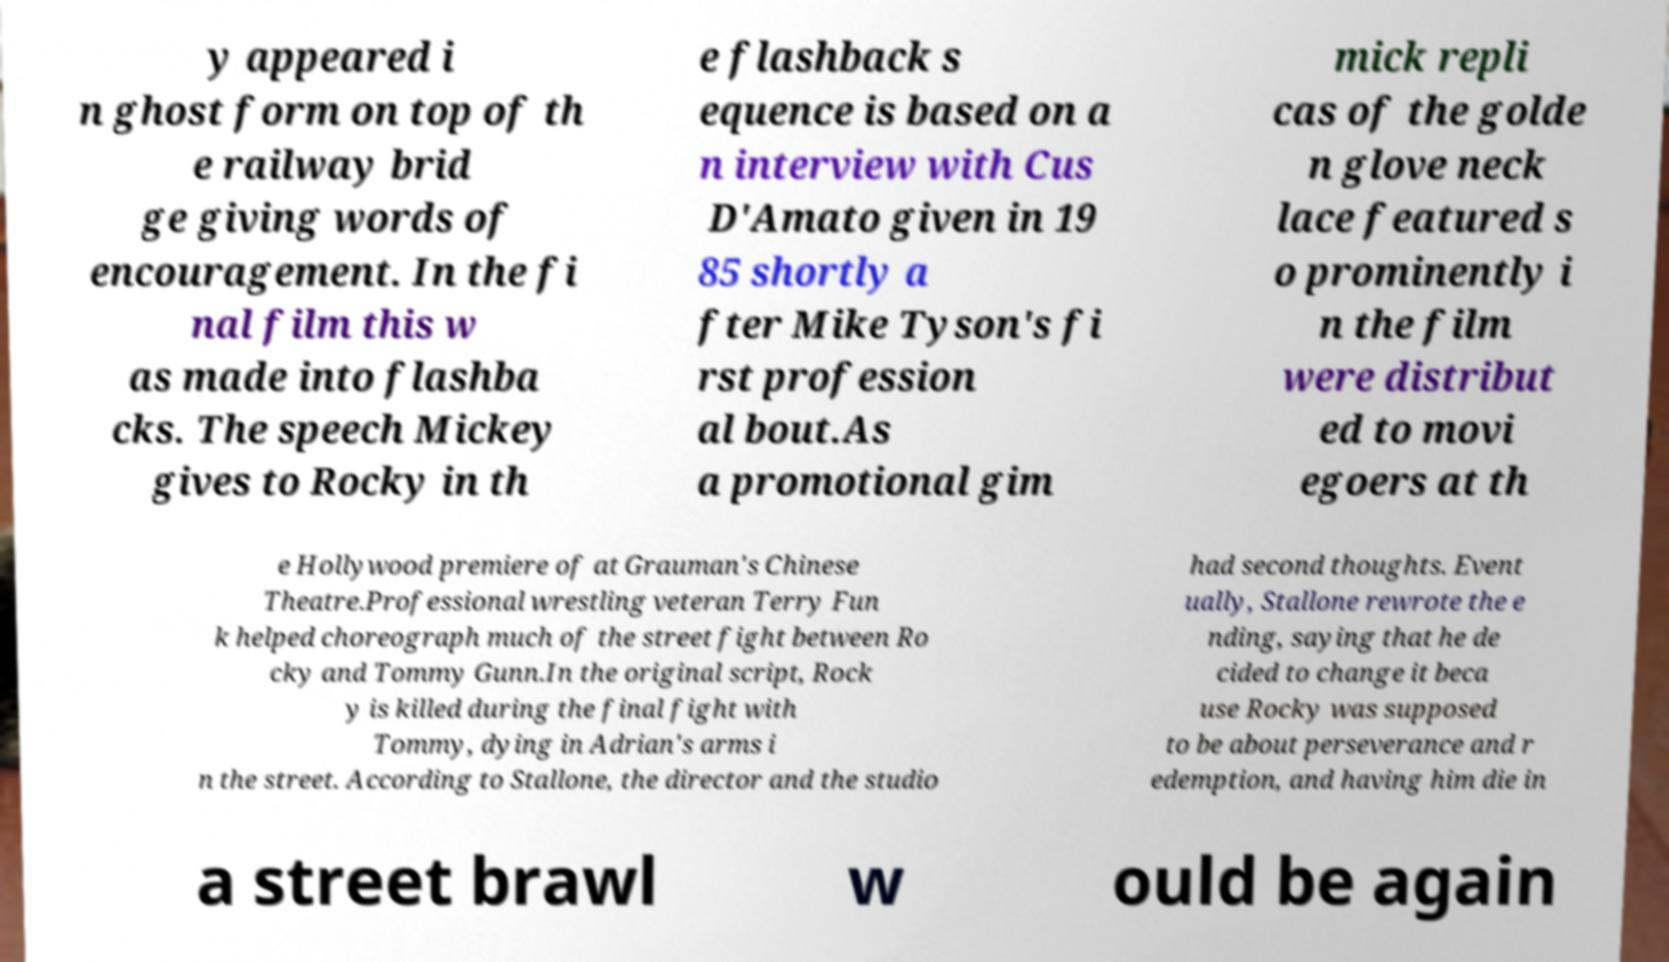There's text embedded in this image that I need extracted. Can you transcribe it verbatim? y appeared i n ghost form on top of th e railway brid ge giving words of encouragement. In the fi nal film this w as made into flashba cks. The speech Mickey gives to Rocky in th e flashback s equence is based on a n interview with Cus D'Amato given in 19 85 shortly a fter Mike Tyson's fi rst profession al bout.As a promotional gim mick repli cas of the golde n glove neck lace featured s o prominently i n the film were distribut ed to movi egoers at th e Hollywood premiere of at Grauman's Chinese Theatre.Professional wrestling veteran Terry Fun k helped choreograph much of the street fight between Ro cky and Tommy Gunn.In the original script, Rock y is killed during the final fight with Tommy, dying in Adrian's arms i n the street. According to Stallone, the director and the studio had second thoughts. Event ually, Stallone rewrote the e nding, saying that he de cided to change it beca use Rocky was supposed to be about perseverance and r edemption, and having him die in a street brawl w ould be again 